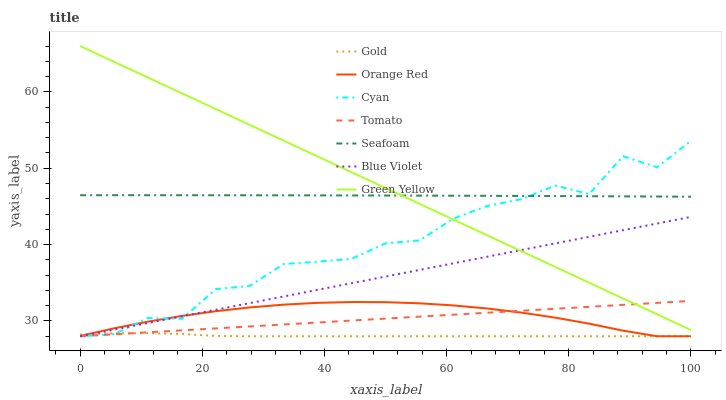Does Gold have the minimum area under the curve?
Answer yes or no. Yes. Does Green Yellow have the maximum area under the curve?
Answer yes or no. Yes. Does Seafoam have the minimum area under the curve?
Answer yes or no. No. Does Seafoam have the maximum area under the curve?
Answer yes or no. No. Is Tomato the smoothest?
Answer yes or no. Yes. Is Cyan the roughest?
Answer yes or no. Yes. Is Gold the smoothest?
Answer yes or no. No. Is Gold the roughest?
Answer yes or no. No. Does Tomato have the lowest value?
Answer yes or no. Yes. Does Seafoam have the lowest value?
Answer yes or no. No. Does Green Yellow have the highest value?
Answer yes or no. Yes. Does Seafoam have the highest value?
Answer yes or no. No. Is Blue Violet less than Seafoam?
Answer yes or no. Yes. Is Seafoam greater than Orange Red?
Answer yes or no. Yes. Does Cyan intersect Tomato?
Answer yes or no. Yes. Is Cyan less than Tomato?
Answer yes or no. No. Is Cyan greater than Tomato?
Answer yes or no. No. Does Blue Violet intersect Seafoam?
Answer yes or no. No. 